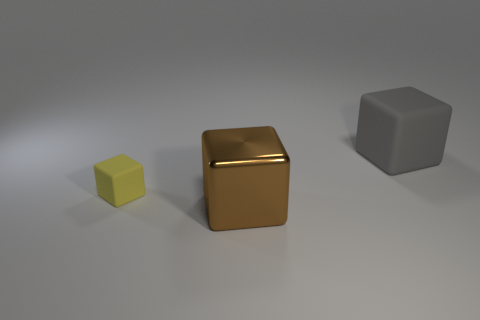Is there anything else that has the same size as the yellow rubber block?
Ensure brevity in your answer.  No. What number of other tiny yellow blocks are the same material as the small cube?
Provide a short and direct response. 0. What number of metal things are big gray cubes or brown things?
Provide a short and direct response. 1. What is the material of the brown cube that is the same size as the gray matte object?
Provide a succinct answer. Metal. Is there a big cyan cylinder that has the same material as the yellow cube?
Your answer should be compact. No. There is a gray matte thing; is its size the same as the cube in front of the small cube?
Give a very brief answer. Yes. What is the shape of the thing that is on the right side of the small block and behind the large brown object?
Your answer should be compact. Cube. How many tiny objects are brown blocks or purple matte blocks?
Keep it short and to the point. 0. Are there an equal number of brown blocks that are to the left of the brown shiny block and rubber blocks to the right of the big rubber object?
Provide a succinct answer. Yes. What number of other things are the same color as the tiny rubber cube?
Give a very brief answer. 0. 